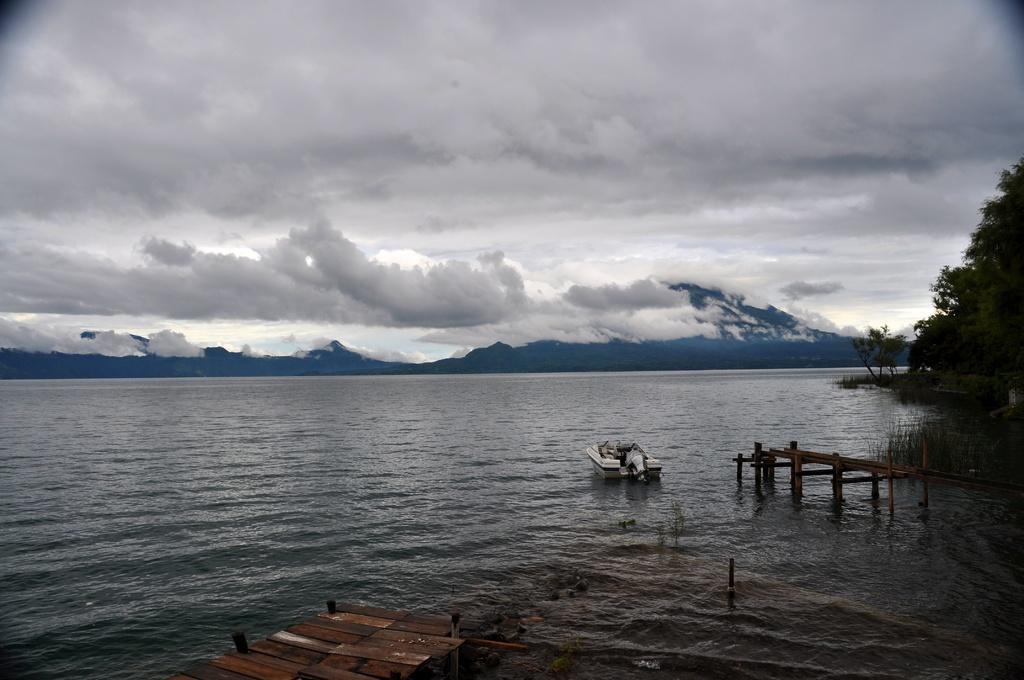Can you describe this image briefly? In this image, we can see a boat on the water and there are board bridges. In the background, there are trees. At the top, there are clouds in the sky. 